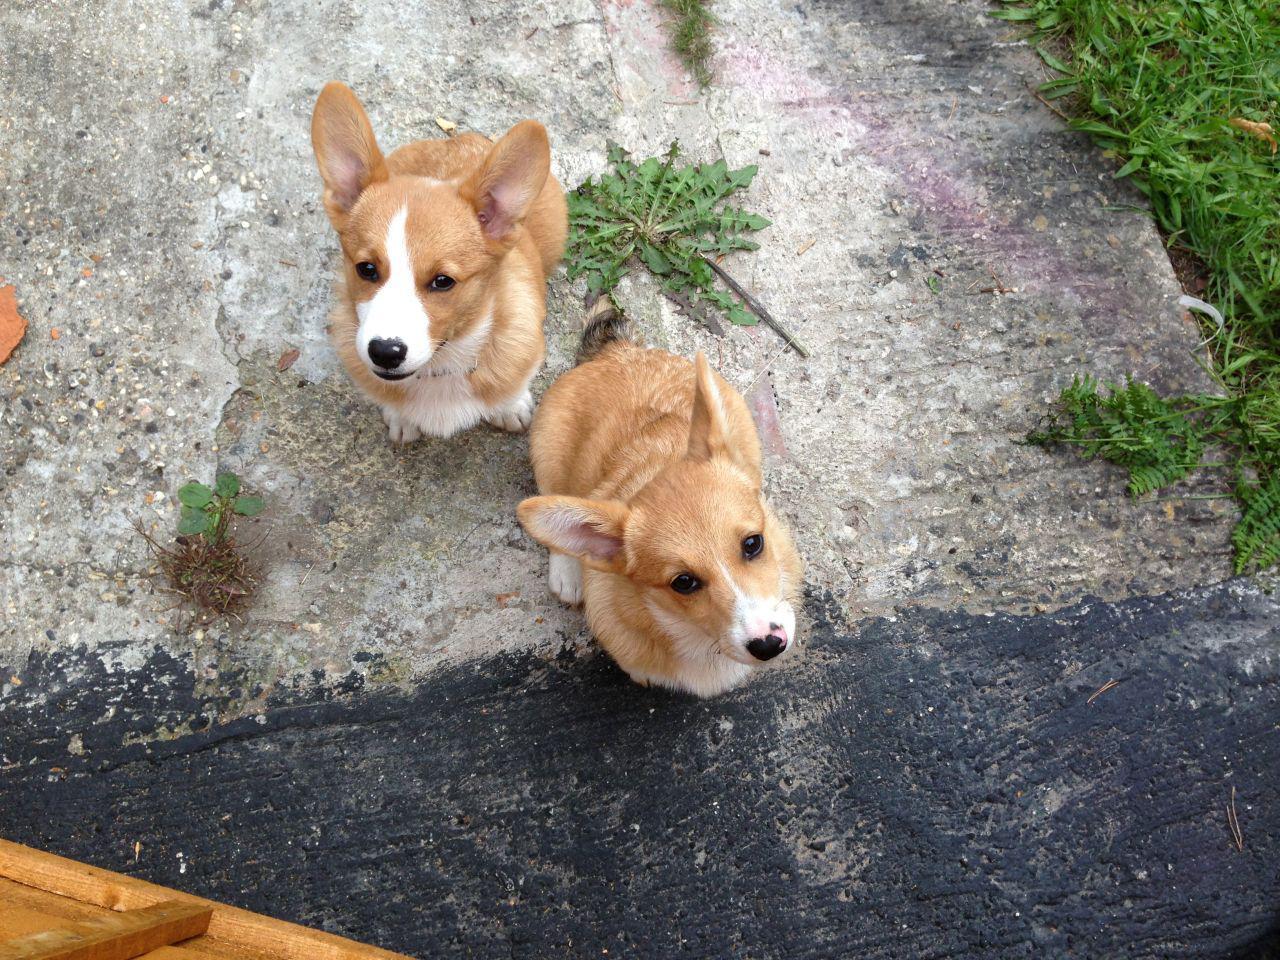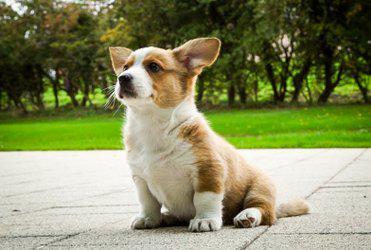The first image is the image on the left, the second image is the image on the right. For the images displayed, is the sentence "There are exactly 3 dogs, and they are all outside." factually correct? Answer yes or no. Yes. The first image is the image on the left, the second image is the image on the right. For the images shown, is this caption "One image shows a corgi standing with its body turned leftward and its smiling face turned to the camera." true? Answer yes or no. No. 